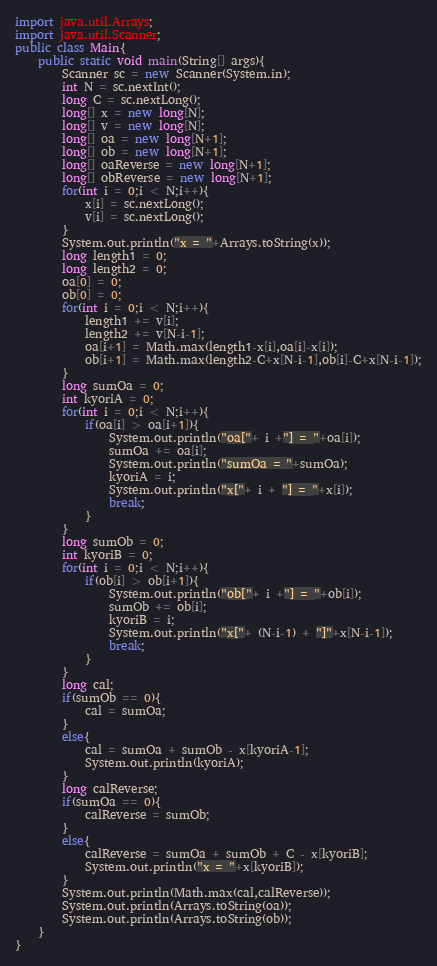Convert code to text. <code><loc_0><loc_0><loc_500><loc_500><_Java_>import java.util.Arrays;
import java.util.Scanner;
public class Main{
    public static void main(String[] args){
        Scanner sc = new Scanner(System.in);
        int N = sc.nextInt();
        long C = sc.nextLong();
        long[] x = new long[N];
        long[] v = new long[N];
        long[] oa = new long[N+1];
        long[] ob = new long[N+1];
        long[] oaReverse = new long[N+1];
        long[] obReverse = new long[N+1];
        for(int i = 0;i < N;i++){
            x[i] = sc.nextLong();
            v[i] = sc.nextLong();
        }
        System.out.println("x = "+Arrays.toString(x));
        long length1 = 0;
        long length2 = 0;
        oa[0] = 0;
        ob[0] = 0;
        for(int i = 0;i < N;i++){
            length1 += v[i];
            length2 += v[N-i-1];
            oa[i+1] = Math.max(length1-x[i],oa[i]-x[i]);
            ob[i+1] = Math.max(length2-C+x[N-i-1],ob[i]-C+x[N-i-1]);
        }
        long sumOa = 0;
        int kyoriA = 0;
        for(int i = 0;i < N;i++){
            if(oa[i] > oa[i+1]){
                System.out.println("oa["+ i +"] = "+oa[i]);
                sumOa += oa[i];
                System.out.println("sumOa = "+sumOa);
                kyoriA = i;
                System.out.println("x["+ i + "] = "+x[i]);
                break;
            }
        }
        long sumOb = 0;
        int kyoriB = 0;
        for(int i = 0;i < N;i++){
            if(ob[i] > ob[i+1]){
                System.out.println("ob["+ i +"] = "+ob[i]);
                sumOb += ob[i];
                kyoriB = i;
                System.out.println("x["+ (N-i-1) + "]"+x[N-i-1]);
                break;
            }
        }
        long cal;
        if(sumOb == 0){
            cal = sumOa;
        }
        else{
            cal = sumOa + sumOb - x[kyoriA-1];
            System.out.println(kyoriA);
        }
        long calReverse;
        if(sumOa == 0){
            calReverse = sumOb;
        }
        else{
            calReverse = sumOa + sumOb + C - x[kyoriB];
            System.out.println("x = "+x[kyoriB]);
        }
        System.out.println(Math.max(cal,calReverse));
        System.out.println(Arrays.toString(oa));
        System.out.println(Arrays.toString(ob));
    }
}

</code> 